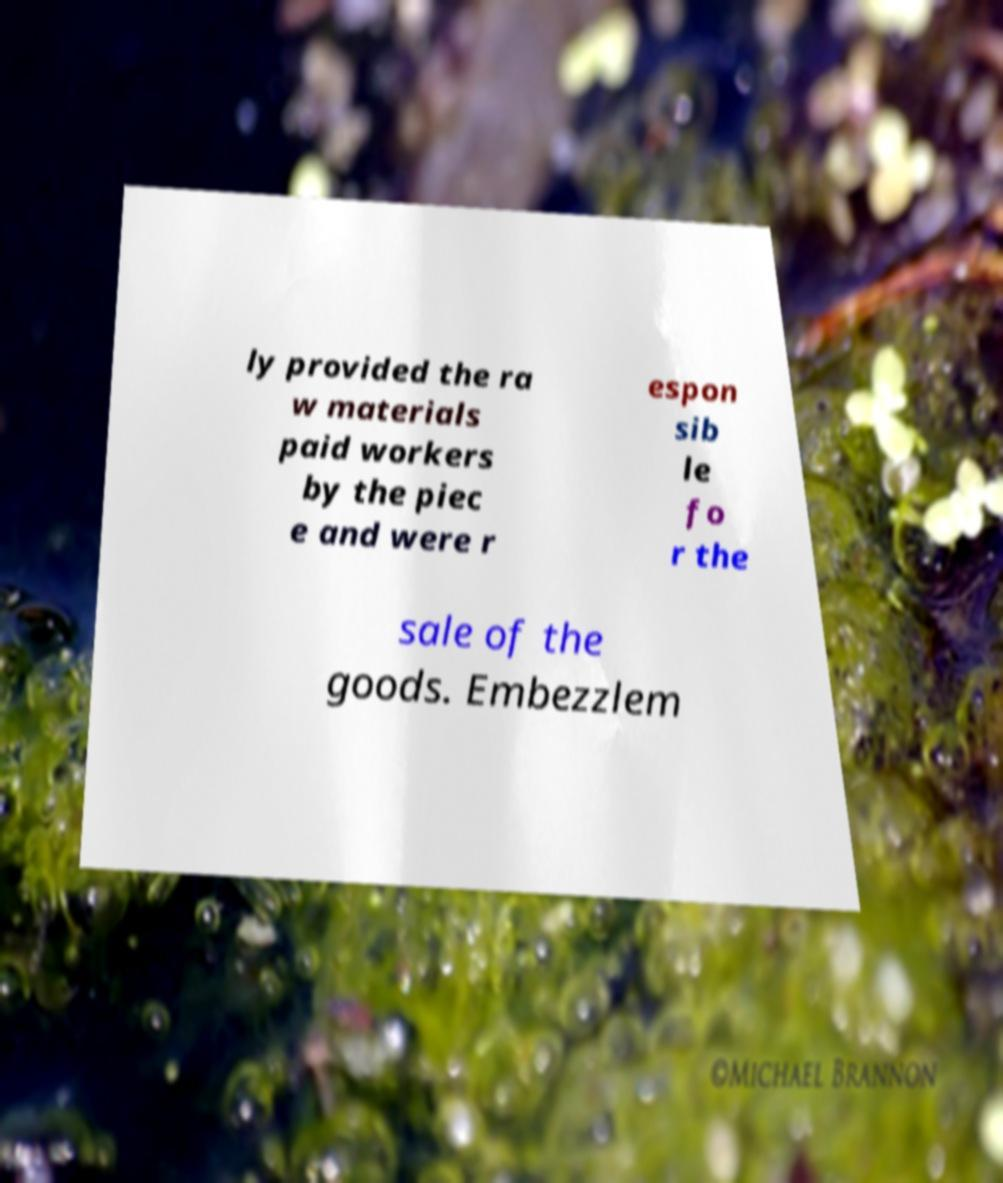For documentation purposes, I need the text within this image transcribed. Could you provide that? ly provided the ra w materials paid workers by the piec e and were r espon sib le fo r the sale of the goods. Embezzlem 